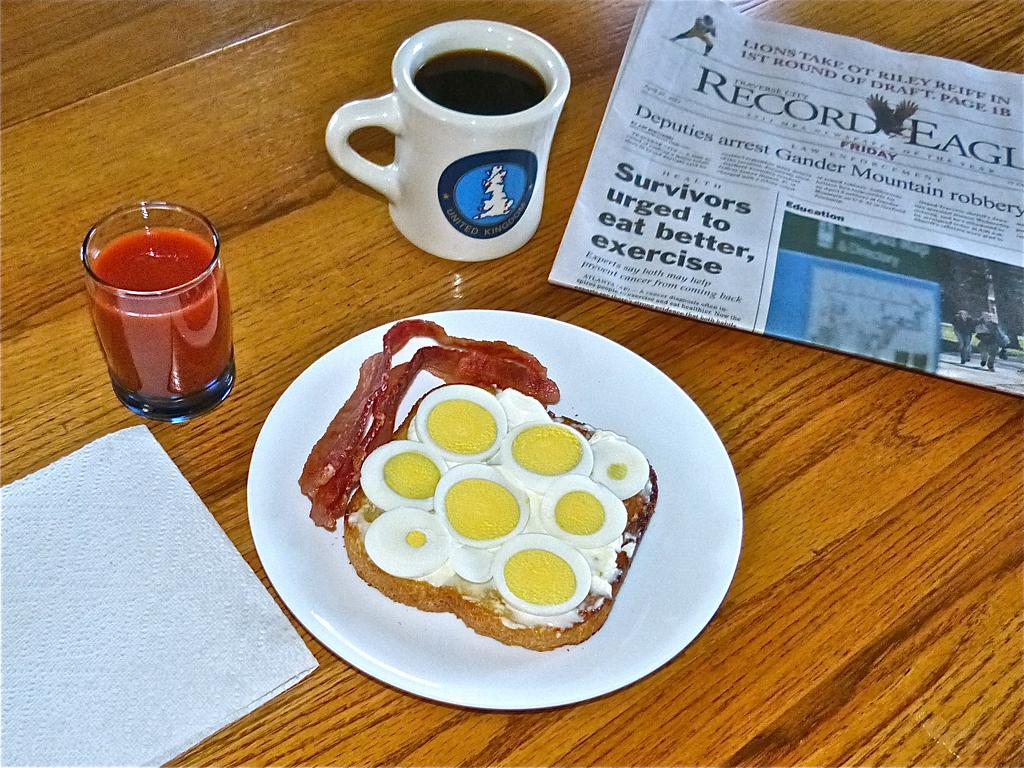What piece of furniture is present in the image? There is a table in the image. What is placed on the table? There is a newspaper, a napkin, a glass, a mug, and a plate containing food on the table. What might be used for cleaning or wiping in the image? A napkin is present in the image for cleaning or wiping. What type of beverage container is visible in the image? There is a glass and a mug on the table. What type of food is present on the plate in the image? The plate contains food, but the specific type of food is not mentioned in the facts. What type of thought can be seen on the plate in the image? There is no thought present on the plate in the image; it contains food. How many apples are visible in the image? There are no apples present in the image. 